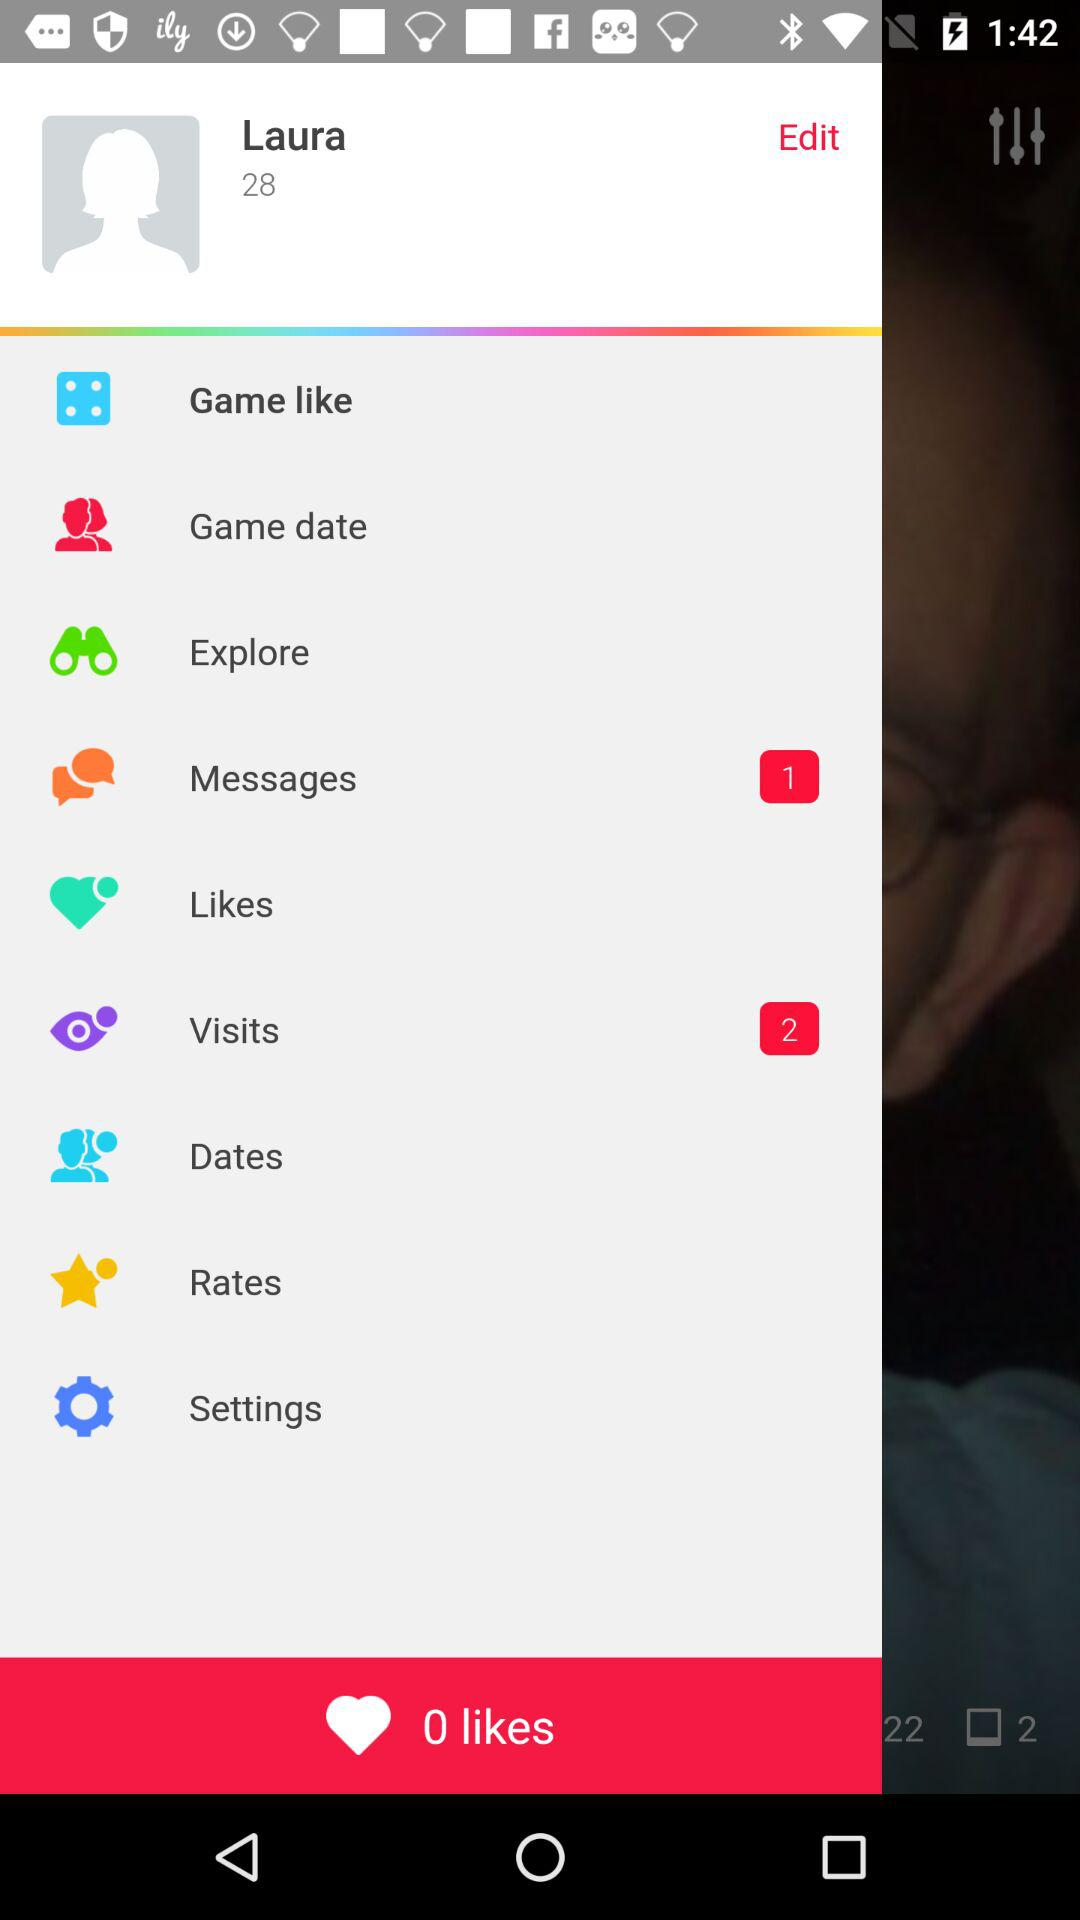What's the user name? The user name is Laura. 